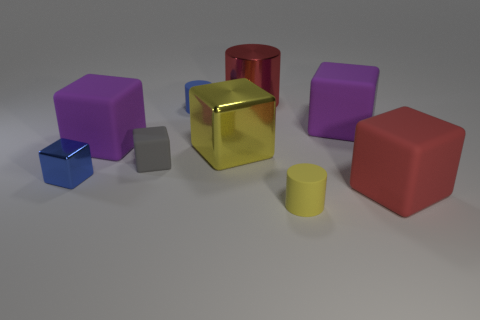Subtract all big cylinders. How many cylinders are left? 2 Add 1 yellow shiny cubes. How many objects exist? 10 Subtract all blue blocks. How many blocks are left? 5 Subtract all cylinders. How many objects are left? 6 Subtract 5 cubes. How many cubes are left? 1 Subtract 1 red cylinders. How many objects are left? 8 Subtract all brown cylinders. Subtract all cyan blocks. How many cylinders are left? 3 Subtract all cyan blocks. How many yellow cylinders are left? 1 Subtract all big metallic things. Subtract all big purple rubber things. How many objects are left? 5 Add 9 gray rubber cubes. How many gray rubber cubes are left? 10 